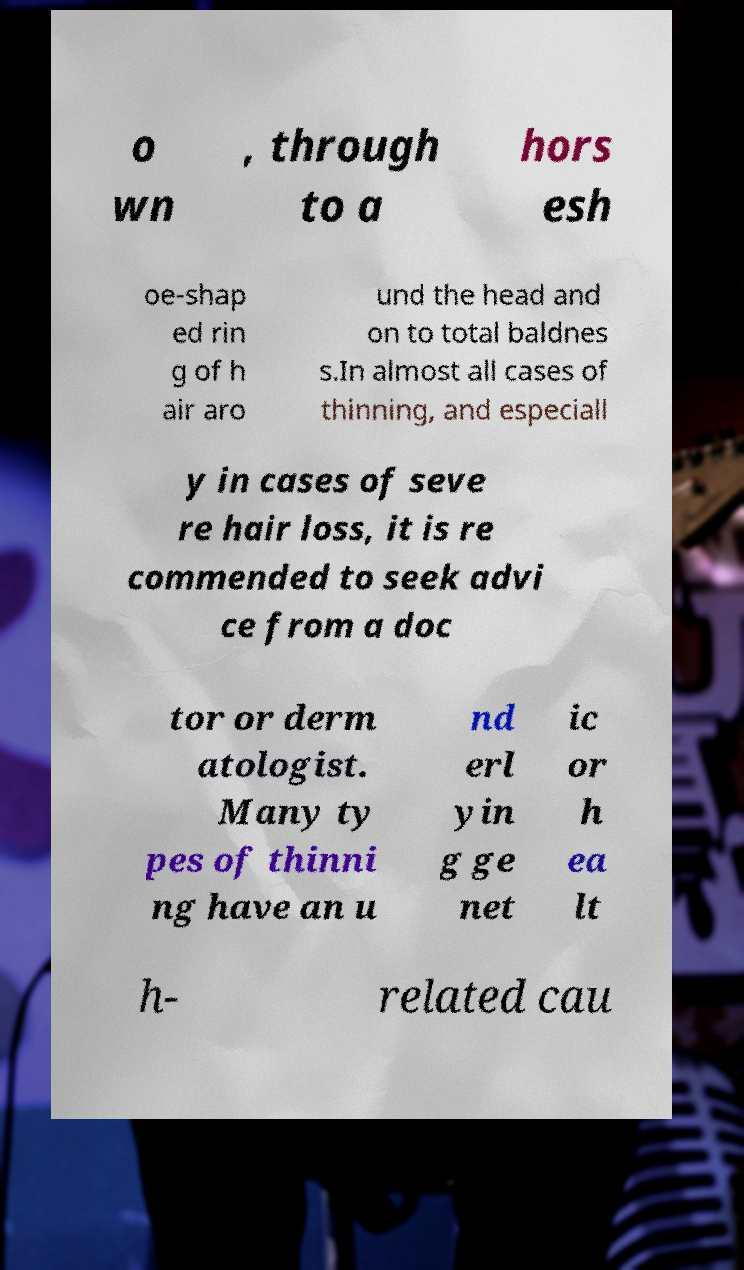Could you extract and type out the text from this image? o wn , through to a hors esh oe-shap ed rin g of h air aro und the head and on to total baldnes s.In almost all cases of thinning, and especiall y in cases of seve re hair loss, it is re commended to seek advi ce from a doc tor or derm atologist. Many ty pes of thinni ng have an u nd erl yin g ge net ic or h ea lt h- related cau 